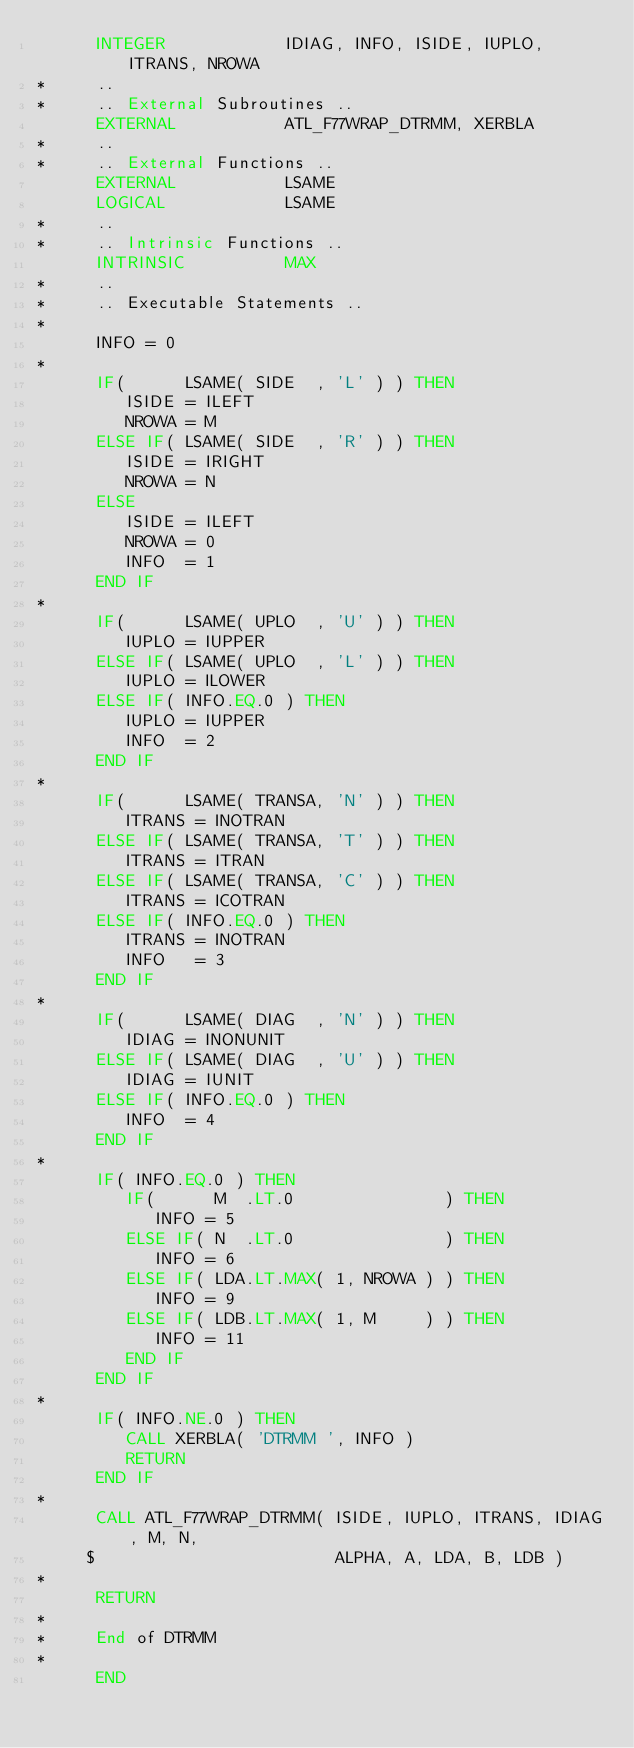<code> <loc_0><loc_0><loc_500><loc_500><_FORTRAN_>      INTEGER            IDIAG, INFO, ISIDE, IUPLO, ITRANS, NROWA
*     ..
*     .. External Subroutines ..
      EXTERNAL           ATL_F77WRAP_DTRMM, XERBLA
*     ..
*     .. External Functions ..
      EXTERNAL           LSAME
      LOGICAL            LSAME
*     ..
*     .. Intrinsic Functions ..
      INTRINSIC          MAX
*     ..
*     .. Executable Statements ..
*
      INFO = 0
*
      IF(      LSAME( SIDE  , 'L' ) ) THEN
         ISIDE = ILEFT
         NROWA = M
      ELSE IF( LSAME( SIDE  , 'R' ) ) THEN
         ISIDE = IRIGHT
         NROWA = N
      ELSE
         ISIDE = ILEFT
         NROWA = 0
         INFO  = 1
      END IF
*
      IF(      LSAME( UPLO  , 'U' ) ) THEN
         IUPLO = IUPPER
      ELSE IF( LSAME( UPLO  , 'L' ) ) THEN
         IUPLO = ILOWER
      ELSE IF( INFO.EQ.0 ) THEN
         IUPLO = IUPPER
         INFO  = 2
      END IF
*
      IF(      LSAME( TRANSA, 'N' ) ) THEN
         ITRANS = INOTRAN
      ELSE IF( LSAME( TRANSA, 'T' ) ) THEN
         ITRANS = ITRAN
      ELSE IF( LSAME( TRANSA, 'C' ) ) THEN
         ITRANS = ICOTRAN
      ELSE IF( INFO.EQ.0 ) THEN
         ITRANS = INOTRAN
         INFO   = 3
      END IF
*
      IF(      LSAME( DIAG  , 'N' ) ) THEN
         IDIAG = INONUNIT
      ELSE IF( LSAME( DIAG  , 'U' ) ) THEN
         IDIAG = IUNIT
      ELSE IF( INFO.EQ.0 ) THEN
         INFO  = 4
      END IF
*
      IF( INFO.EQ.0 ) THEN
         IF(      M  .LT.0               ) THEN
            INFO = 5
         ELSE IF( N  .LT.0               ) THEN
            INFO = 6
         ELSE IF( LDA.LT.MAX( 1, NROWA ) ) THEN
            INFO = 9
         ELSE IF( LDB.LT.MAX( 1, M     ) ) THEN
            INFO = 11
         END IF
      END IF
*
      IF( INFO.NE.0 ) THEN
         CALL XERBLA( 'DTRMM ', INFO )
         RETURN
      END IF
*
      CALL ATL_F77WRAP_DTRMM( ISIDE, IUPLO, ITRANS, IDIAG, M, N,
     $                        ALPHA, A, LDA, B, LDB )
*
      RETURN
*
*     End of DTRMM
*
      END
</code> 